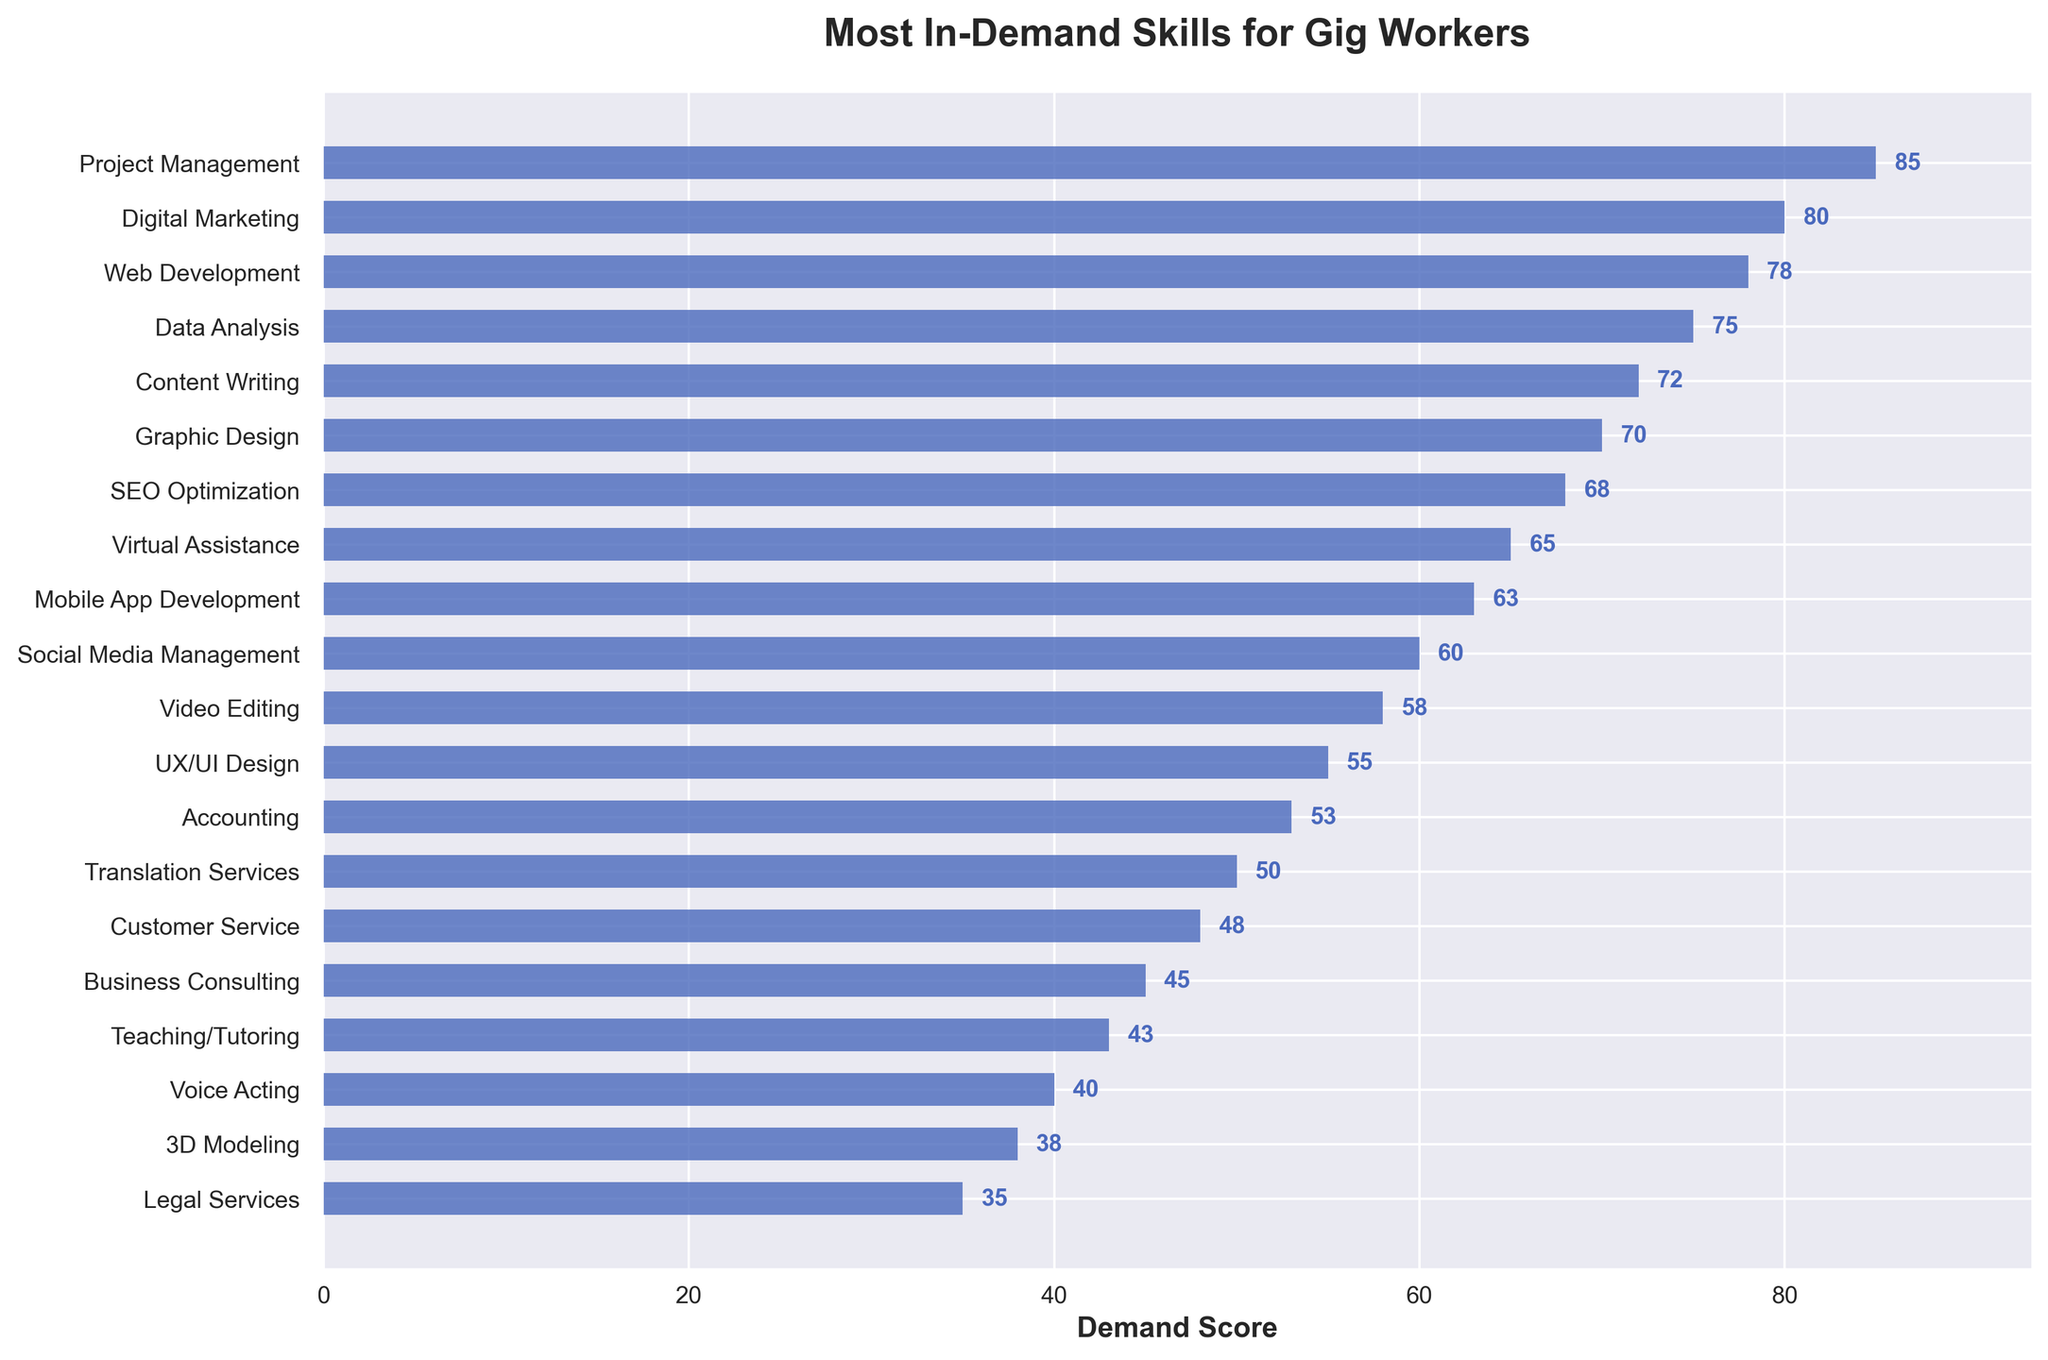Which skill has the highest demand score? The highest demand score is represented by the bar reaching the farthest to the right. The longest bar corresponds to Project Management.
Answer: Project Management Which skill has a demand score of 60? Find the bar that reaches up to the value of 60 along the x-axis. This bar corresponds to Social Media Management.
Answer: Social Media Management Which skill shows a demand score closest to the average demand score of all listed skills? To find the average, sum all the demand scores and divide by the number of skills. The sum of the demand scores is 1056, and there are 20 skills listed, so the average score is 1056 / 20 = 52.8. The skill with the demand score closest to this value is Accounting with a score of 53.
Answer: Accounting Compare the demand scores of Web Development and Data Analysis. Which one is higher, and by how much? Find the bars labeled Web Development and Data Analysis and their respective heights. Web Development has a score of 78 and Data Analysis has a score of 75. The difference is 78 - 75 = 3.
Answer: Web Development, by 3 How much higher is the demand score for Digital Marketing compared to SEO Optimization? Locate the bars for Digital Marketing and SEO Optimization and determine their respective heights. Digital Marketing has a score of 80, and SEO Optimization has a score of 68. The difference is 80 - 68 = 12.
Answer: 12 Which skill has the second lowest demand score? The smallest bar represents the lowest demand score, Legal Services. The bar just above it represents the second lowest score. This bar corresponds to Voice Acting.
Answer: Voice Acting What is the cumulative demand score for the three most in-demand skills? Identify the three skills with the highest demand scores: Project Management (85), Digital Marketing (80), and Web Development (78). The sum is 85 + 80 + 78 = 243.
Answer: 243 Which skill has a demand score between Content Writing and Graphic Design? Content Writing has a score of 72 and Graphic Design has a score of 70. The skill with the score between these two values is Data Analysis with a score of 75.
Answer: Data Analysis How many skills have a demand score above 70? Count the number of bars that extend beyond the 70 mark along the x-axis: Project Management, Digital Marketing, Web Development, Data Analysis, and Content Writing.
Answer: 5 